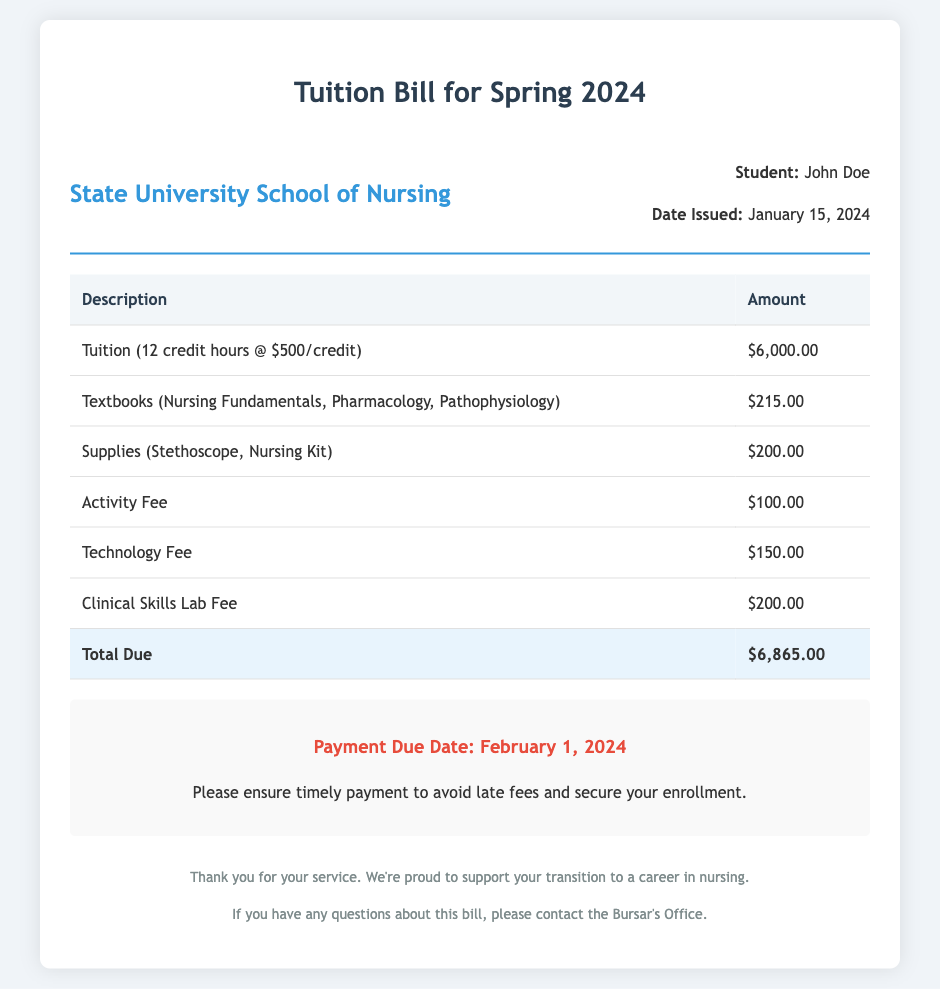What is the total amount due? The total amount due is clearly stated in the document as the sum of all fees, which is $6,865.00.
Answer: $6,865.00 When is the payment due date? The payment due date is explicitly mentioned in the payment information section of the document.
Answer: February 1, 2024 What is the tuition cost for 12 credit hours? The document specifies the tuition cost for 12 credit hours as $500 per credit hour.
Answer: $6,000.00 What is included in the supplies cost? The supplies cost includes specific items listed in the document, which are a stethoscope and a nursing kit.
Answer: Stethoscope, Nursing Kit How much is the Clinical Skills Lab Fee? The Clinical Skills Lab Fee is outlined in the table and is a component of the overall tuition bill.
Answer: $200.00 What is the total of the activity and technology fees combined? The question requires summing the individual fees for better understanding, which are $100 for activity and $150 for technology.
Answer: $250.00 Who is the student listed on the bill? The student's name is provided in the header section of the document for identification.
Answer: John Doe What are the required textbooks for the semester? The document lists the required textbooks directly under the course materials section.
Answer: Nursing Fundamentals, Pharmacology, Pathophysiology What institution issued the bill? The institution's name is featured prominently at the top of the document.
Answer: State University School of Nursing 